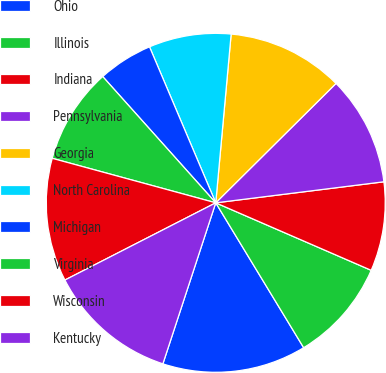Convert chart. <chart><loc_0><loc_0><loc_500><loc_500><pie_chart><fcel>Ohio<fcel>Illinois<fcel>Indiana<fcel>Pennsylvania<fcel>Georgia<fcel>North Carolina<fcel>Michigan<fcel>Virginia<fcel>Wisconsin<fcel>Kentucky<nl><fcel>13.73%<fcel>9.8%<fcel>8.5%<fcel>10.46%<fcel>11.11%<fcel>7.84%<fcel>5.23%<fcel>9.15%<fcel>11.76%<fcel>12.42%<nl></chart> 